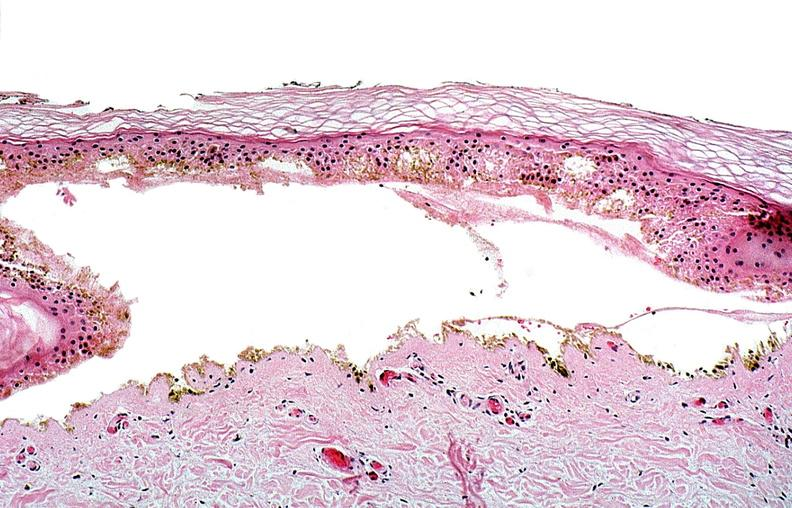does chloramphenicol toxicity show thermal burned skin?
Answer the question using a single word or phrase. No 